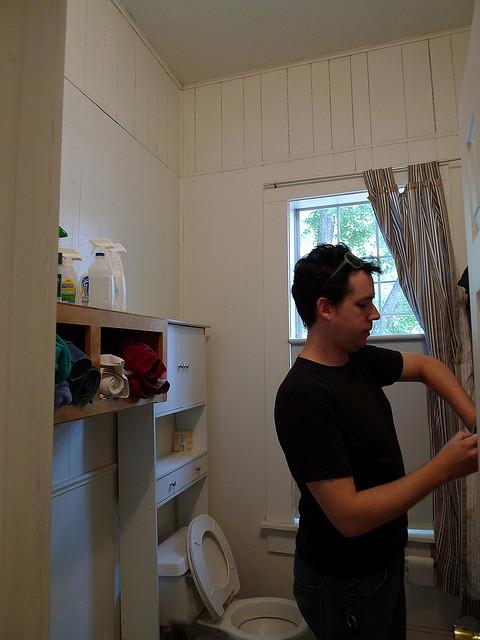Is the curtain closed?
Concise answer only. No. What color is the walls?
Be succinct. White. How many people are in the picture?
Short answer required. 1. Is the toilet seat up?
Answer briefly. Yes. What is this person holding?
Be succinct. Soap. How many cabinets?
Write a very short answer. 2. Is the man standing?
Write a very short answer. Yes. 